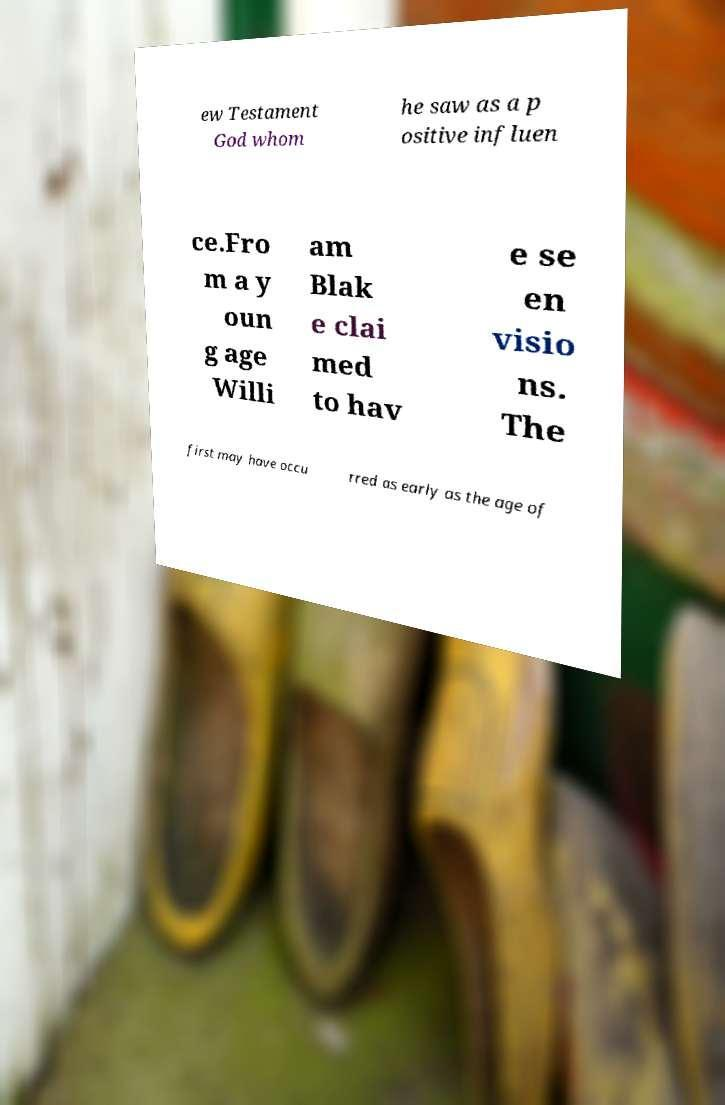Could you extract and type out the text from this image? ew Testament God whom he saw as a p ositive influen ce.Fro m a y oun g age Willi am Blak e clai med to hav e se en visio ns. The first may have occu rred as early as the age of 